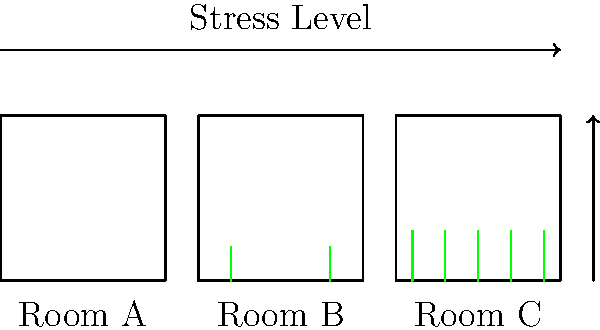Based on the illustration, which room configuration is likely to result in the lowest stress levels and highest attention span for children in a pediatric psychiatric setting? To answer this question, we need to analyze the information provided in the diagram:

1. Room configurations:
   - Room A: No plants
   - Room B: Few plants
   - Room C: Many plants

2. Stress level representation:
   - The horizontal axis at the top represents stress levels.
   - Red dots indicate stress levels for each room.
   - Lower position of red dots indicates lower stress levels.

3. Attention span representation:
   - The vertical axis on the right represents attention span.
   - Blue dots indicate attention span for each room.
   - Higher position of blue dots indicates higher attention span.

4. Analyzing the data:
   - Room A (No plants):
     * Highest stress level (red dot at the top)
     * Lowest attention span (lowest blue dot)
   - Room B (Few plants):
     * Medium stress level (red dot in the middle)
     * Medium attention span (middle blue dot)
   - Room C (Many plants):
     * Lowest stress level (lowest red dot)
     * Highest attention span (highest blue dot)

5. Conclusion:
   Room C, with many plants, shows the lowest stress level and highest attention span for children in a pediatric psychiatric setting.

This aligns with research suggesting that exposure to nature and greenery can reduce stress and improve cognitive function, which is particularly relevant in pediatric psychiatric environments.
Answer: Room C (Many plants) 